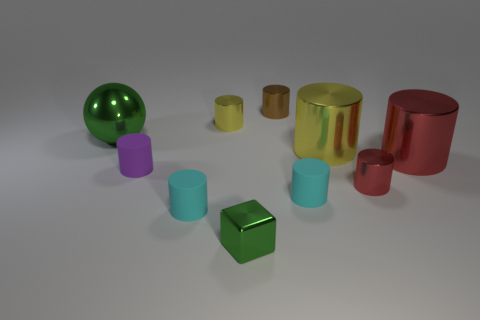Subtract all shiny cylinders. How many cylinders are left? 3 Subtract all yellow cylinders. How many cylinders are left? 6 Subtract all blue balls. How many yellow cylinders are left? 2 Subtract 6 cylinders. How many cylinders are left? 2 Add 1 green balls. How many green balls exist? 2 Subtract 0 cyan cubes. How many objects are left? 10 Subtract all spheres. How many objects are left? 9 Subtract all green cylinders. Subtract all brown blocks. How many cylinders are left? 8 Subtract all tiny purple cubes. Subtract all green metallic objects. How many objects are left? 8 Add 1 small metallic things. How many small metallic things are left? 5 